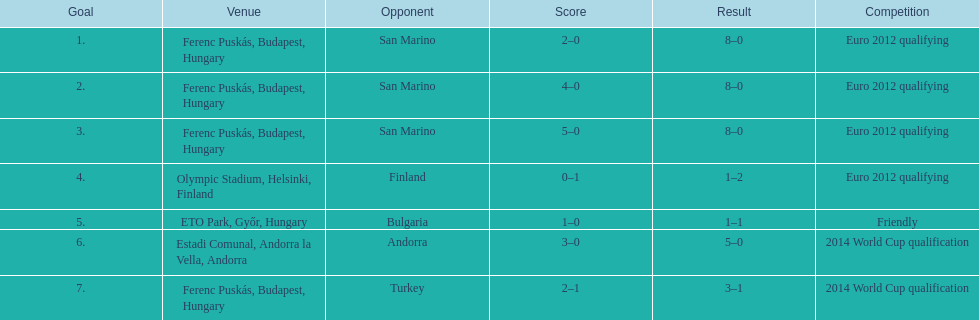Szalai scored only one more international goal against all other countries put together than he did against what one country? San Marino. 